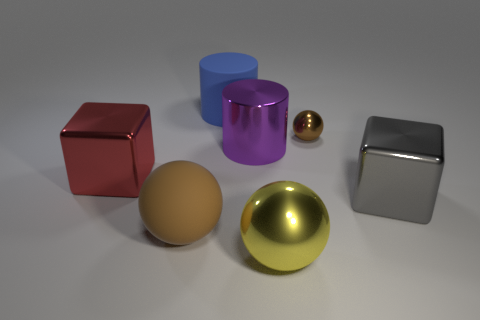What is the material of the purple cylinder that is the same size as the gray metallic cube?
Provide a short and direct response. Metal. Are there any large blue cylinders that have the same material as the large brown sphere?
Your answer should be very brief. Yes. The big thing that is both right of the purple thing and behind the yellow metallic ball is what color?
Offer a terse response. Gray. What number of other things are the same color as the tiny object?
Your answer should be compact. 1. The block that is in front of the shiny cube that is behind the thing that is right of the small metallic object is made of what material?
Make the answer very short. Metal. How many cylinders are large blue things or yellow objects?
Provide a short and direct response. 1. Are there any other things that have the same size as the brown shiny ball?
Offer a very short reply. No. There is a big metal cube that is on the left side of the large rubber object in front of the gray metallic thing; what number of tiny objects are to the left of it?
Offer a very short reply. 0. Is the large blue matte object the same shape as the yellow thing?
Provide a succinct answer. No. Does the big ball in front of the big brown ball have the same material as the cylinder in front of the small ball?
Your response must be concise. Yes. 